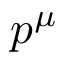<formula> <loc_0><loc_0><loc_500><loc_500>p ^ { \mu }</formula> 